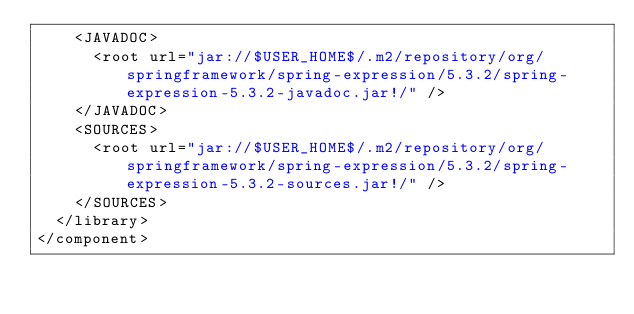<code> <loc_0><loc_0><loc_500><loc_500><_XML_>    <JAVADOC>
      <root url="jar://$USER_HOME$/.m2/repository/org/springframework/spring-expression/5.3.2/spring-expression-5.3.2-javadoc.jar!/" />
    </JAVADOC>
    <SOURCES>
      <root url="jar://$USER_HOME$/.m2/repository/org/springframework/spring-expression/5.3.2/spring-expression-5.3.2-sources.jar!/" />
    </SOURCES>
  </library>
</component></code> 